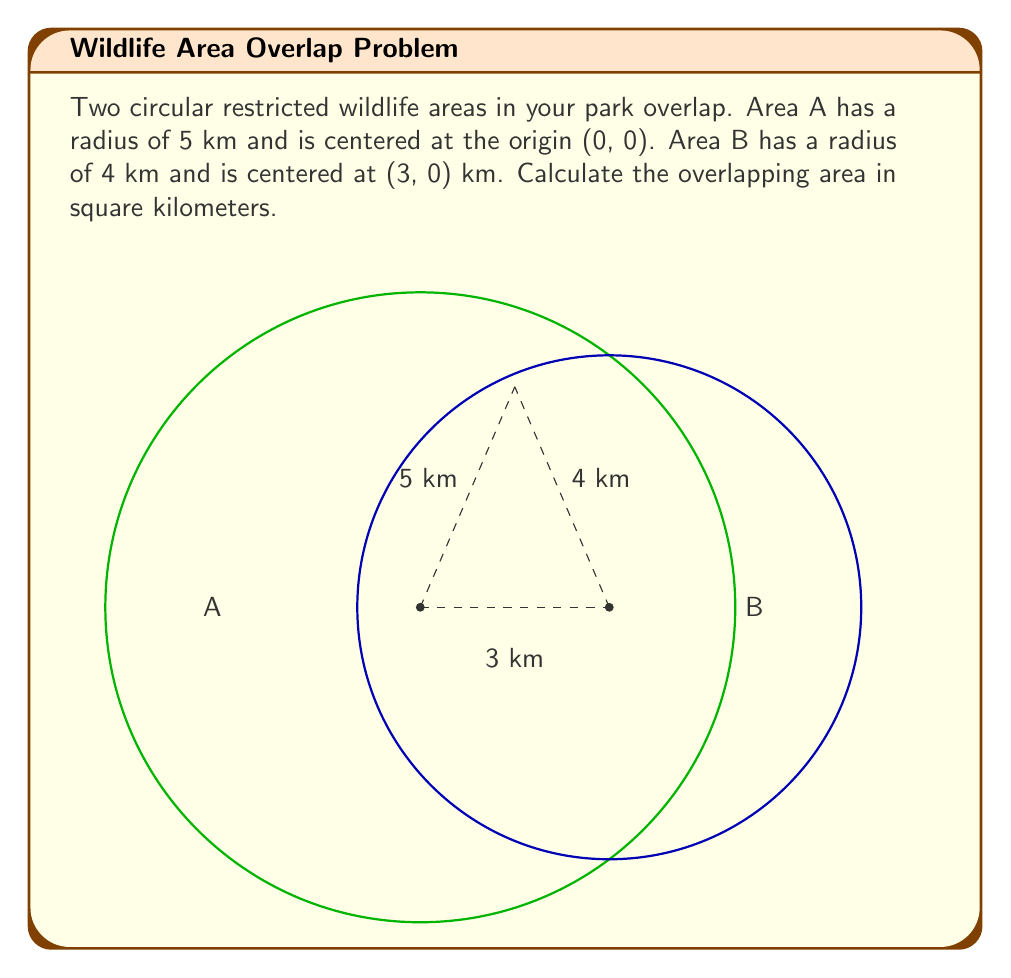Can you solve this math problem? To solve this problem, we'll use the formula for the area of intersection of two circles. Let's break it down step-by-step:

1) First, we need to find the distance $d$ between the centers of the two circles:
   $d = 3$ km (given in the problem)

2) Let $R = 5$ km (radius of circle A) and $r = 4$ km (radius of circle B)

3) The formula for the area of intersection is:

   $$A = R^2 \arccos(\frac{d^2 + R^2 - r^2}{2dR}) + r^2 \arccos(\frac{d^2 + r^2 - R^2}{2dr}) - \frac{1}{2}\sqrt{(-d+r+R)(d+r-R)(d-r+R)(d+r+R)}$$

4) Let's calculate each part:

   a) $\arccos(\frac{d^2 + R^2 - r^2}{2dR}) = \arccos(\frac{3^2 + 5^2 - 4^2}{2 \cdot 3 \cdot 5}) = \arccos(0.7) = 0.7953$ radians
   
   b) $\arccos(\frac{d^2 + r^2 - R^2}{2dr}) = \arccos(\frac{3^2 + 4^2 - 5^2}{2 \cdot 3 \cdot 4}) = \arccos(0.2917) = 1.2739$ radians
   
   c) $\sqrt{(-d+r+R)(d+r-R)(d-r+R)(d+r+R)} = \sqrt{(1)(2)(4)(12)} = \sqrt{96} = 9.7980$

5) Now, let's put it all together:

   $$A = 5^2 \cdot 0.7953 + 4^2 \cdot 1.2739 - \frac{1}{2} \cdot 9.7980$$
   $$A = 19.8825 + 20.3824 - 4.8990$$
   $$A = 35.3659 \text{ km}^2$$
Answer: The overlapping area is approximately 35.37 square kilometers. 